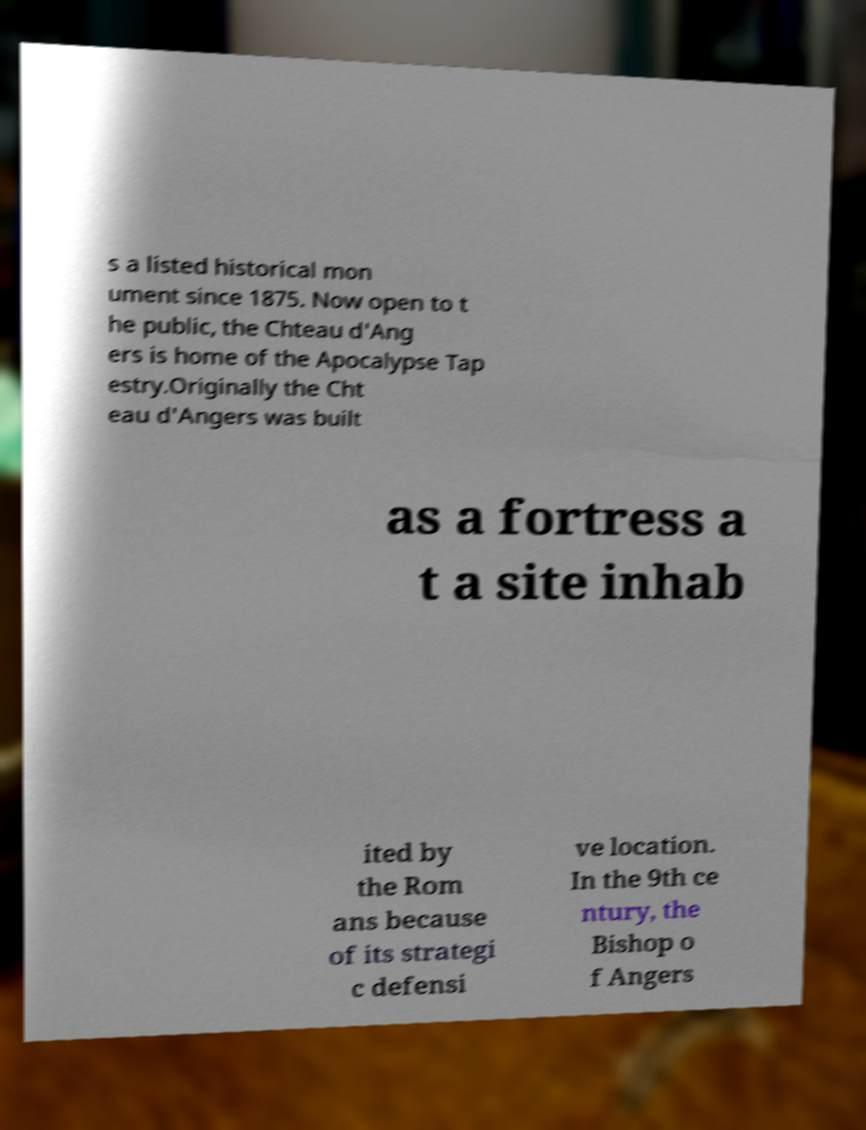For documentation purposes, I need the text within this image transcribed. Could you provide that? s a listed historical mon ument since 1875. Now open to t he public, the Chteau d'Ang ers is home of the Apocalypse Tap estry.Originally the Cht eau d'Angers was built as a fortress a t a site inhab ited by the Rom ans because of its strategi c defensi ve location. In the 9th ce ntury, the Bishop o f Angers 